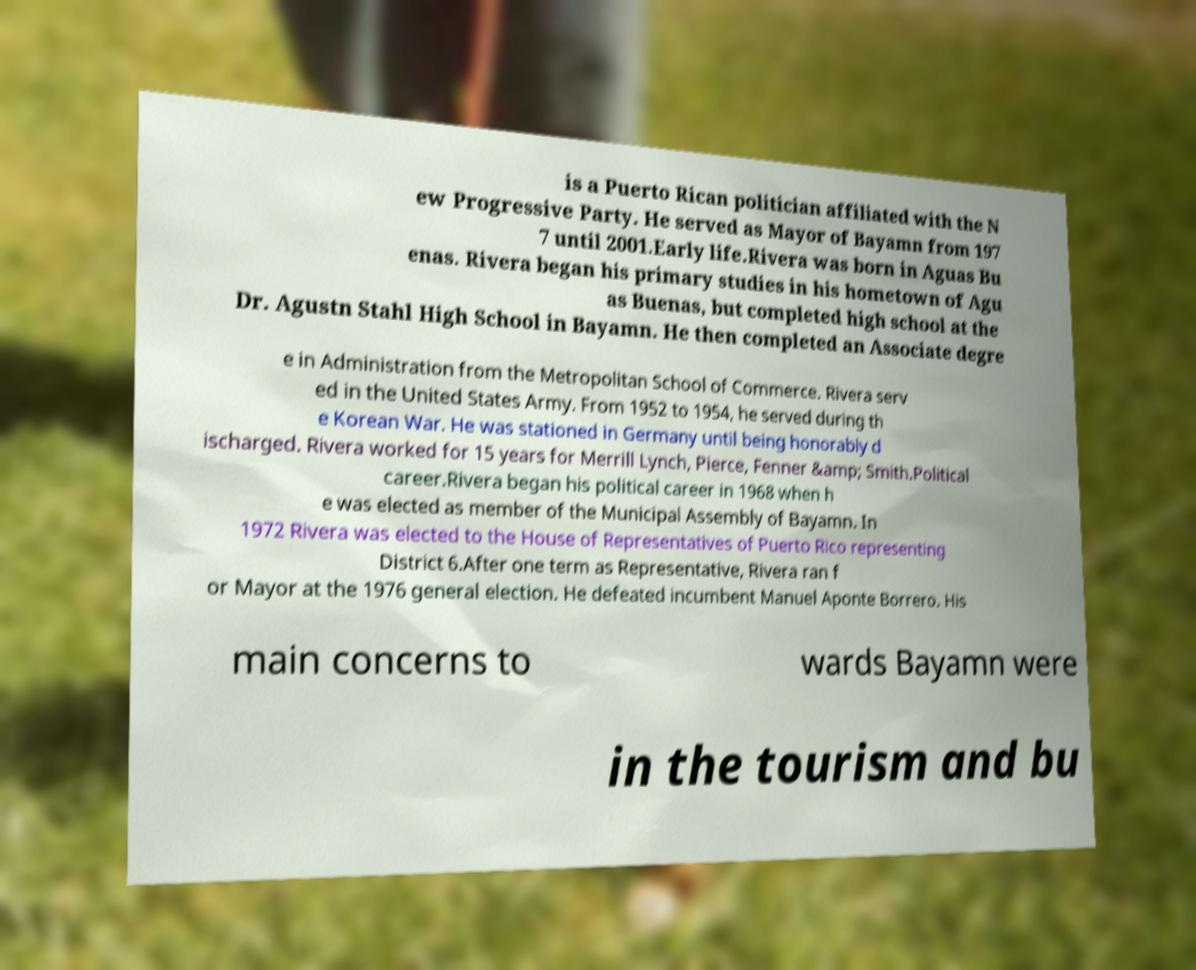Can you accurately transcribe the text from the provided image for me? is a Puerto Rican politician affiliated with the N ew Progressive Party. He served as Mayor of Bayamn from 197 7 until 2001.Early life.Rivera was born in Aguas Bu enas. Rivera began his primary studies in his hometown of Agu as Buenas, but completed high school at the Dr. Agustn Stahl High School in Bayamn. He then completed an Associate degre e in Administration from the Metropolitan School of Commerce. Rivera serv ed in the United States Army. From 1952 to 1954, he served during th e Korean War. He was stationed in Germany until being honorably d ischarged. Rivera worked for 15 years for Merrill Lynch, Pierce, Fenner &amp; Smith.Political career.Rivera began his political career in 1968 when h e was elected as member of the Municipal Assembly of Bayamn. In 1972 Rivera was elected to the House of Representatives of Puerto Rico representing District 6.After one term as Representative, Rivera ran f or Mayor at the 1976 general election. He defeated incumbent Manuel Aponte Borrero. His main concerns to wards Bayamn were in the tourism and bu 